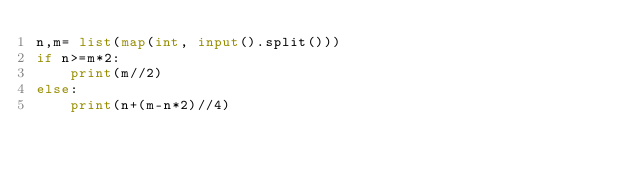<code> <loc_0><loc_0><loc_500><loc_500><_Python_>n,m= list(map(int, input().split()))
if n>=m*2:
    print(m//2)
else:
    print(n+(m-n*2)//4)</code> 